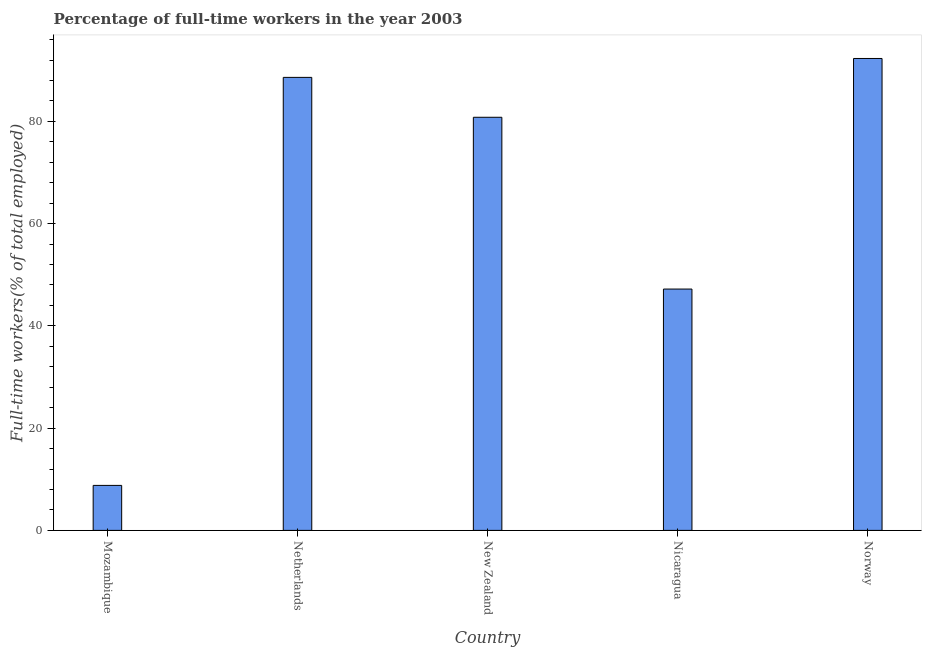Does the graph contain any zero values?
Your response must be concise. No. Does the graph contain grids?
Make the answer very short. No. What is the title of the graph?
Give a very brief answer. Percentage of full-time workers in the year 2003. What is the label or title of the X-axis?
Offer a very short reply. Country. What is the label or title of the Y-axis?
Your response must be concise. Full-time workers(% of total employed). What is the percentage of full-time workers in Nicaragua?
Your answer should be compact. 47.2. Across all countries, what is the maximum percentage of full-time workers?
Make the answer very short. 92.3. Across all countries, what is the minimum percentage of full-time workers?
Give a very brief answer. 8.8. In which country was the percentage of full-time workers maximum?
Offer a very short reply. Norway. In which country was the percentage of full-time workers minimum?
Offer a terse response. Mozambique. What is the sum of the percentage of full-time workers?
Provide a short and direct response. 317.7. What is the difference between the percentage of full-time workers in Nicaragua and Norway?
Ensure brevity in your answer.  -45.1. What is the average percentage of full-time workers per country?
Your response must be concise. 63.54. What is the median percentage of full-time workers?
Your answer should be compact. 80.8. In how many countries, is the percentage of full-time workers greater than 72 %?
Keep it short and to the point. 3. What is the difference between the highest and the second highest percentage of full-time workers?
Provide a succinct answer. 3.7. Is the sum of the percentage of full-time workers in Nicaragua and Norway greater than the maximum percentage of full-time workers across all countries?
Provide a succinct answer. Yes. What is the difference between the highest and the lowest percentage of full-time workers?
Your answer should be compact. 83.5. Are all the bars in the graph horizontal?
Offer a terse response. No. What is the difference between two consecutive major ticks on the Y-axis?
Provide a short and direct response. 20. What is the Full-time workers(% of total employed) in Mozambique?
Ensure brevity in your answer.  8.8. What is the Full-time workers(% of total employed) of Netherlands?
Offer a terse response. 88.6. What is the Full-time workers(% of total employed) in New Zealand?
Provide a succinct answer. 80.8. What is the Full-time workers(% of total employed) of Nicaragua?
Provide a succinct answer. 47.2. What is the Full-time workers(% of total employed) in Norway?
Give a very brief answer. 92.3. What is the difference between the Full-time workers(% of total employed) in Mozambique and Netherlands?
Your answer should be compact. -79.8. What is the difference between the Full-time workers(% of total employed) in Mozambique and New Zealand?
Make the answer very short. -72. What is the difference between the Full-time workers(% of total employed) in Mozambique and Nicaragua?
Ensure brevity in your answer.  -38.4. What is the difference between the Full-time workers(% of total employed) in Mozambique and Norway?
Give a very brief answer. -83.5. What is the difference between the Full-time workers(% of total employed) in Netherlands and New Zealand?
Provide a succinct answer. 7.8. What is the difference between the Full-time workers(% of total employed) in Netherlands and Nicaragua?
Keep it short and to the point. 41.4. What is the difference between the Full-time workers(% of total employed) in New Zealand and Nicaragua?
Your response must be concise. 33.6. What is the difference between the Full-time workers(% of total employed) in Nicaragua and Norway?
Make the answer very short. -45.1. What is the ratio of the Full-time workers(% of total employed) in Mozambique to that in Netherlands?
Your answer should be compact. 0.1. What is the ratio of the Full-time workers(% of total employed) in Mozambique to that in New Zealand?
Offer a terse response. 0.11. What is the ratio of the Full-time workers(% of total employed) in Mozambique to that in Nicaragua?
Provide a succinct answer. 0.19. What is the ratio of the Full-time workers(% of total employed) in Mozambique to that in Norway?
Offer a terse response. 0.1. What is the ratio of the Full-time workers(% of total employed) in Netherlands to that in New Zealand?
Keep it short and to the point. 1.1. What is the ratio of the Full-time workers(% of total employed) in Netherlands to that in Nicaragua?
Your answer should be compact. 1.88. What is the ratio of the Full-time workers(% of total employed) in New Zealand to that in Nicaragua?
Your answer should be very brief. 1.71. What is the ratio of the Full-time workers(% of total employed) in Nicaragua to that in Norway?
Provide a short and direct response. 0.51. 